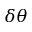<formula> <loc_0><loc_0><loc_500><loc_500>\delta \theta</formula> 